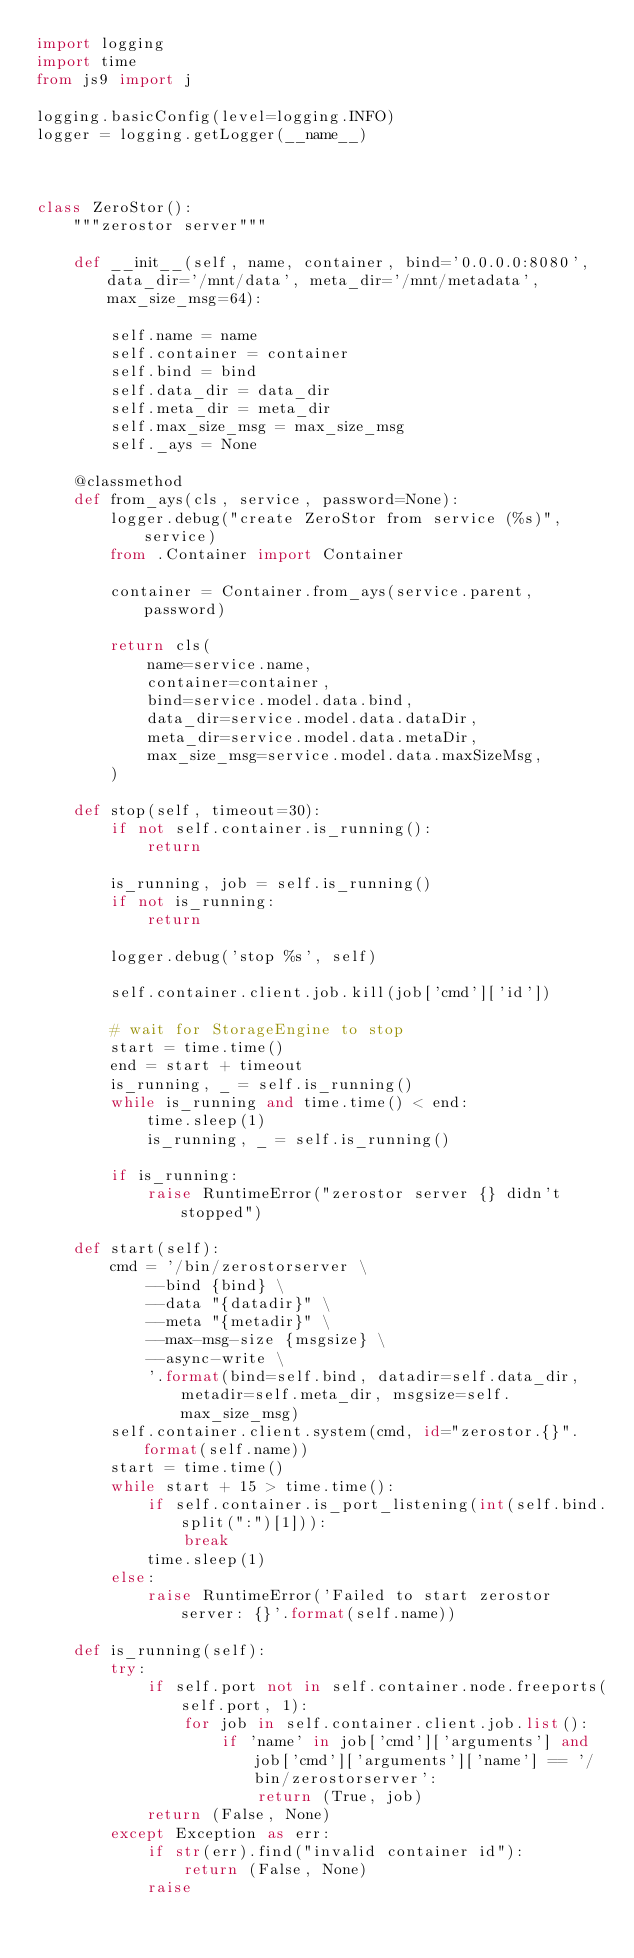Convert code to text. <code><loc_0><loc_0><loc_500><loc_500><_Python_>import logging
import time
from js9 import j

logging.basicConfig(level=logging.INFO)
logger = logging.getLogger(__name__)



class ZeroStor():
    """zerostor server"""

    def __init__(self, name, container, bind='0.0.0.0:8080', data_dir='/mnt/data', meta_dir='/mnt/metadata', max_size_msg=64):

        self.name = name
        self.container = container
        self.bind = bind
        self.data_dir = data_dir
        self.meta_dir = meta_dir
        self.max_size_msg = max_size_msg
        self._ays = None

    @classmethod
    def from_ays(cls, service, password=None):
        logger.debug("create ZeroStor from service (%s)", service)
        from .Container import Container

        container = Container.from_ays(service.parent, password)

        return cls(
            name=service.name,
            container=container,
            bind=service.model.data.bind,
            data_dir=service.model.data.dataDir,
            meta_dir=service.model.data.metaDir,
            max_size_msg=service.model.data.maxSizeMsg,
        )

    def stop(self, timeout=30):
        if not self.container.is_running():
            return

        is_running, job = self.is_running()
        if not is_running:
            return

        logger.debug('stop %s', self)

        self.container.client.job.kill(job['cmd']['id'])

        # wait for StorageEngine to stop
        start = time.time()
        end = start + timeout
        is_running, _ = self.is_running()
        while is_running and time.time() < end:
            time.sleep(1)
            is_running, _ = self.is_running()

        if is_running:
            raise RuntimeError("zerostor server {} didn't stopped")

    def start(self):
        cmd = '/bin/zerostorserver \
            --bind {bind} \
            --data "{datadir}" \
            --meta "{metadir}" \
            --max-msg-size {msgsize} \
            --async-write \
            '.format(bind=self.bind, datadir=self.data_dir, metadir=self.meta_dir, msgsize=self.max_size_msg)
        self.container.client.system(cmd, id="zerostor.{}".format(self.name))
        start = time.time()
        while start + 15 > time.time():
            if self.container.is_port_listening(int(self.bind.split(":")[1])):
                break
            time.sleep(1)
        else:
            raise RuntimeError('Failed to start zerostor server: {}'.format(self.name))

    def is_running(self):
        try:
            if self.port not in self.container.node.freeports(self.port, 1):
                for job in self.container.client.job.list():
                    if 'name' in job['cmd']['arguments'] and job['cmd']['arguments']['name'] == '/bin/zerostorserver':
                        return (True, job)
            return (False, None)
        except Exception as err:
            if str(err).find("invalid container id"):
                return (False, None)
            raise
</code> 